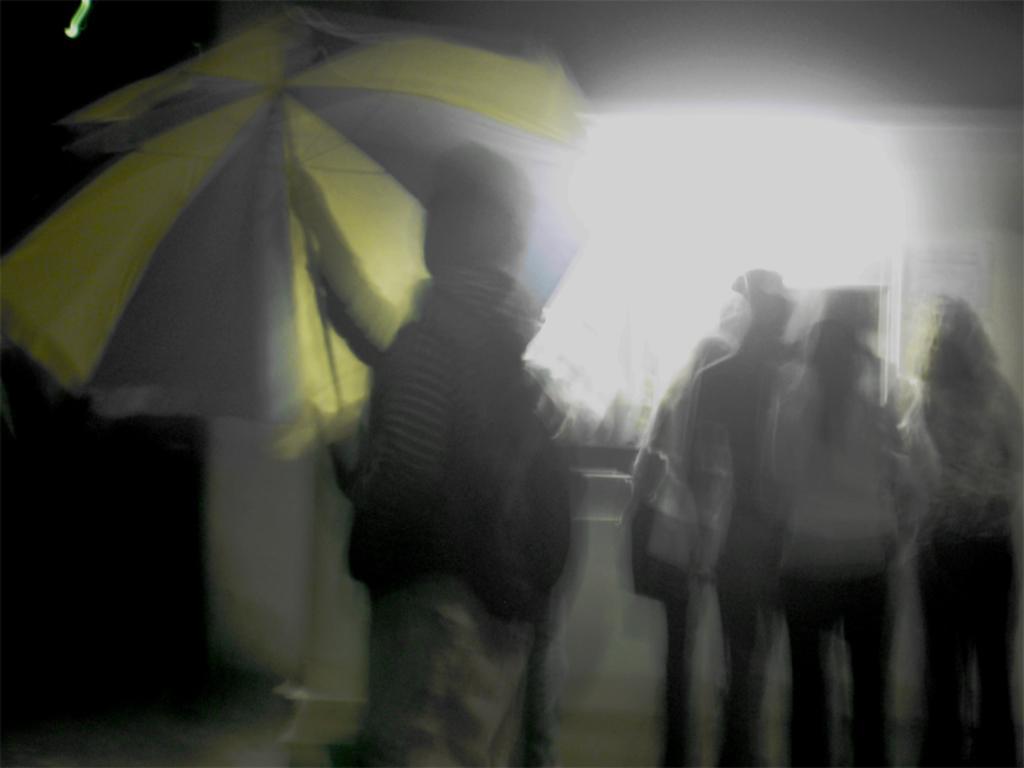Describe this image in one or two sentences. This image consists of some persons. This looks like blurred image. There is a person in the middle. He is holding an umbrella. 